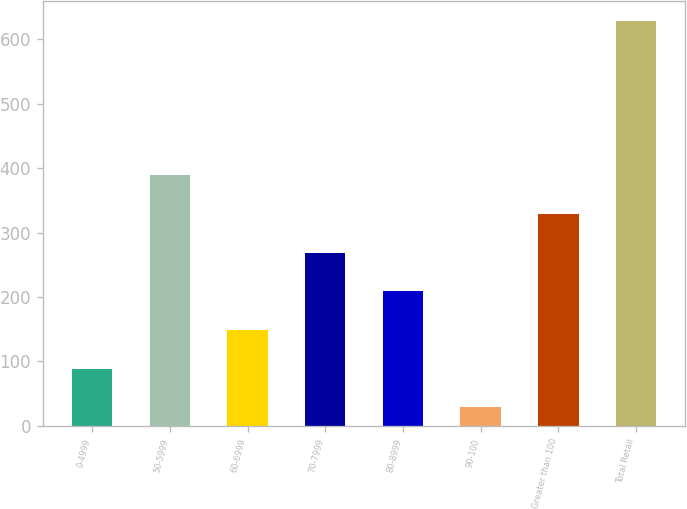<chart> <loc_0><loc_0><loc_500><loc_500><bar_chart><fcel>0-4999<fcel>50-5999<fcel>60-6999<fcel>70-7999<fcel>80-8999<fcel>90-100<fcel>Greater than 100<fcel>Total Retail<nl><fcel>89<fcel>389<fcel>149<fcel>269<fcel>209<fcel>29<fcel>329<fcel>629<nl></chart> 